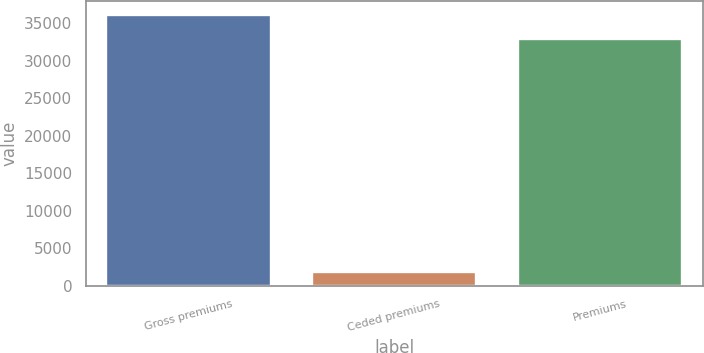Convert chart to OTSL. <chart><loc_0><loc_0><loc_500><loc_500><bar_chart><fcel>Gross premiums<fcel>Ceded premiums<fcel>Premiums<nl><fcel>36087.7<fcel>1778<fcel>32807<nl></chart> 